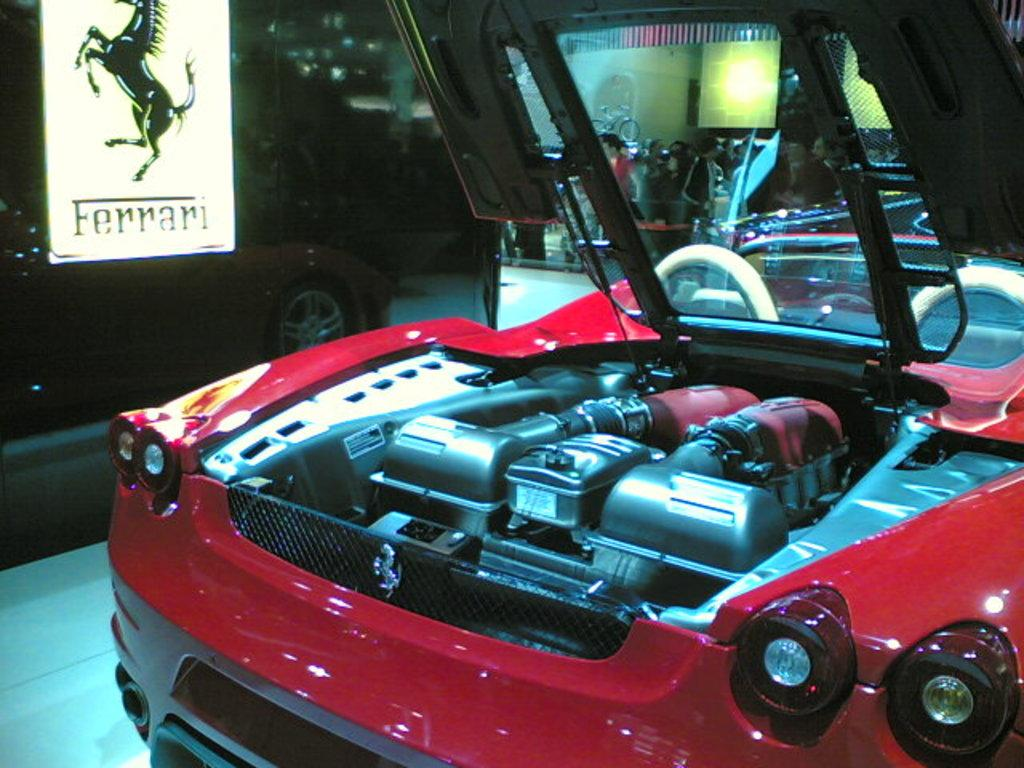What type of object is the main subject in the image? There is a vehicle in the image. What surface is visible in the image? The image contains a floor. What is the board used for in the image? The purpose of the board in the image is not specified, but it is present. What material is transparent in the image? Glass is present in the image. What source of illumination is visible in the image? There is a light in the image. How many girls are holding letters in the image? There are no girls or letters present in the image. What type of airplane can be seen flying in the image? There is no airplane visible in the image. 